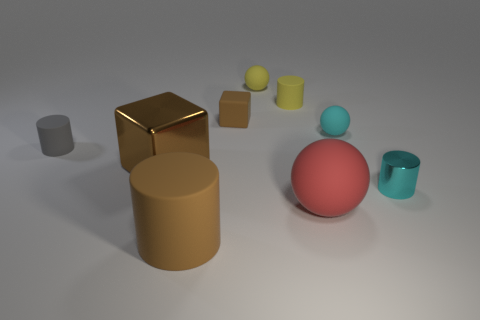Subtract all big cylinders. How many cylinders are left? 3 Subtract all red spheres. How many spheres are left? 2 Subtract all spheres. How many objects are left? 6 Add 1 yellow balls. How many objects exist? 10 Subtract 1 cylinders. How many cylinders are left? 3 Subtract all gray spheres. Subtract all blue cubes. How many spheres are left? 3 Subtract all yellow cylinders. Subtract all small gray objects. How many objects are left? 7 Add 4 cyan rubber things. How many cyan rubber things are left? 5 Add 9 small yellow metal objects. How many small yellow metal objects exist? 9 Subtract 0 green blocks. How many objects are left? 9 